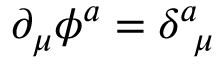<formula> <loc_0><loc_0><loc_500><loc_500>\partial _ { \mu } \phi ^ { a } = \delta _ { \mu } ^ { a }</formula> 